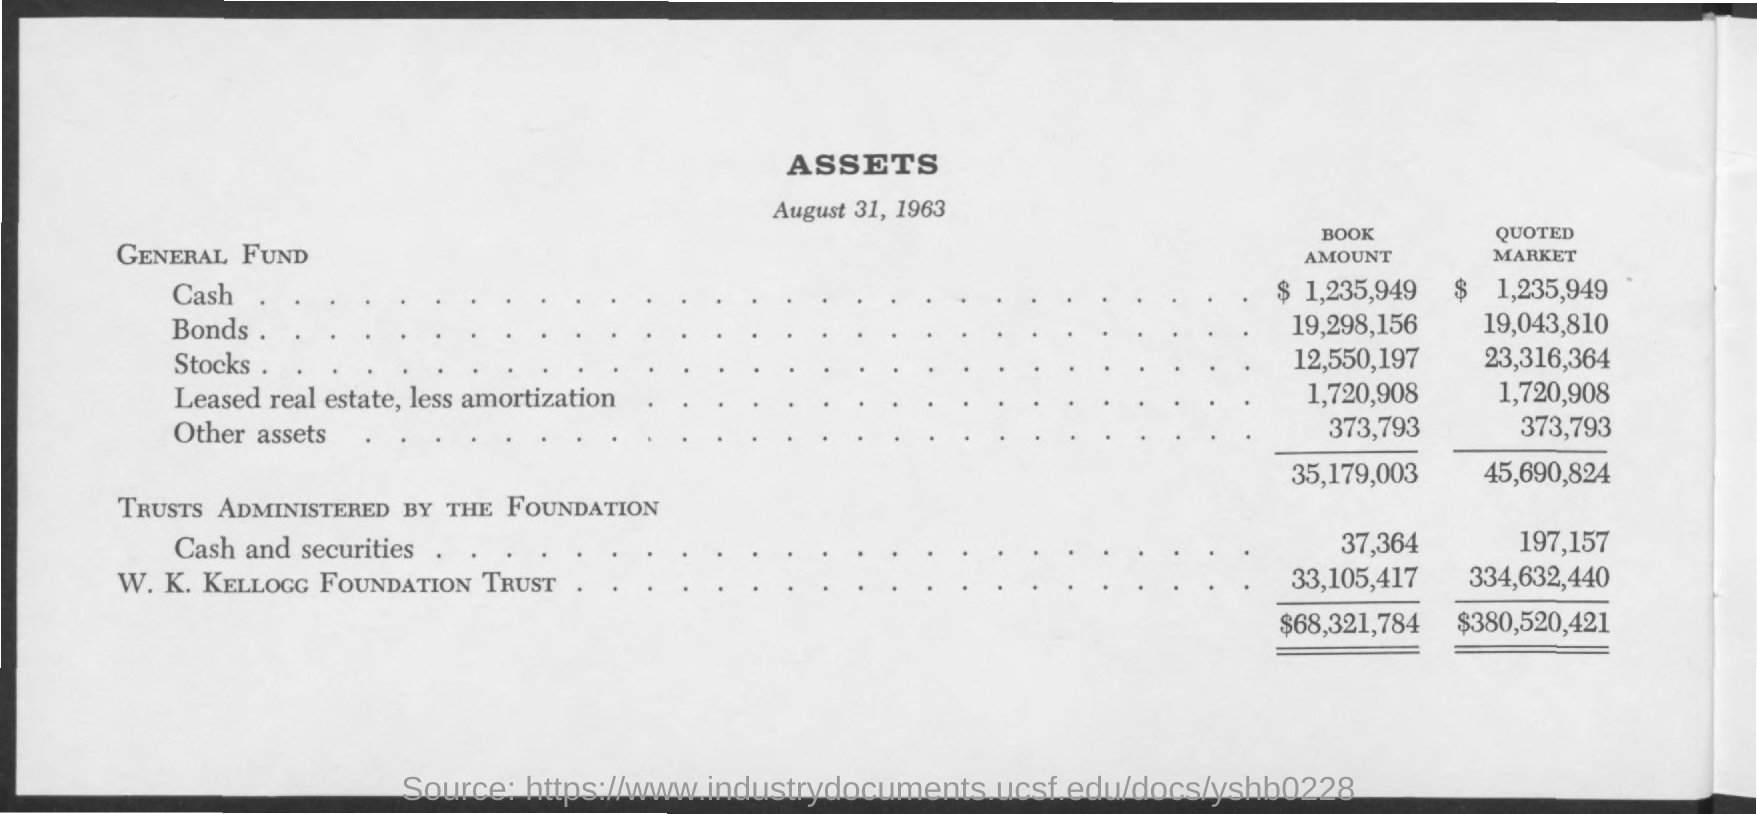Indicate a few pertinent items in this graphic. The title of the document is Assets. This assets report was created on August 31, 1963. 